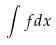Convert formula to latex. <formula><loc_0><loc_0><loc_500><loc_500>\int f d x</formula> 